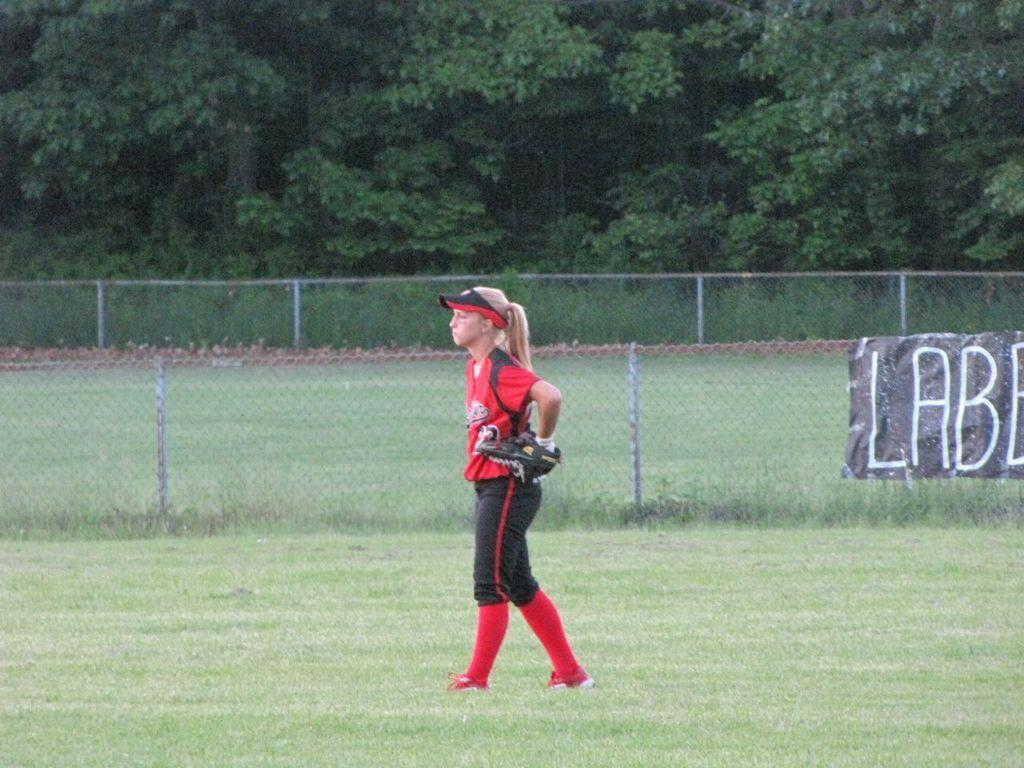<image>
Provide a brief description of the given image. a girl standing near a LAB sign near her 